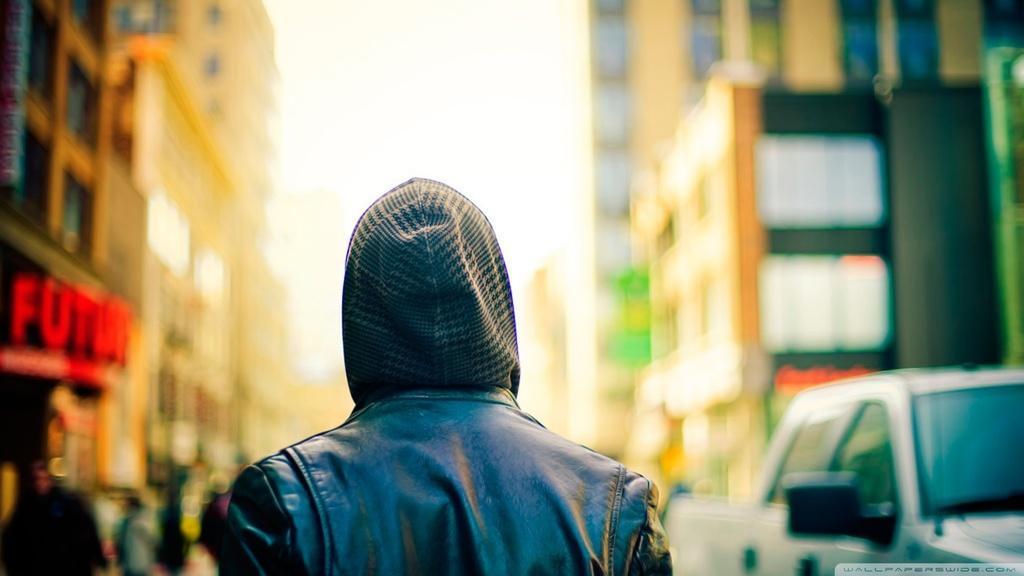Can you describe this image briefly? In this image I can see a crowd, vehicles on the road, building, boards and the sky. This image is taken may be during a day on the road. 